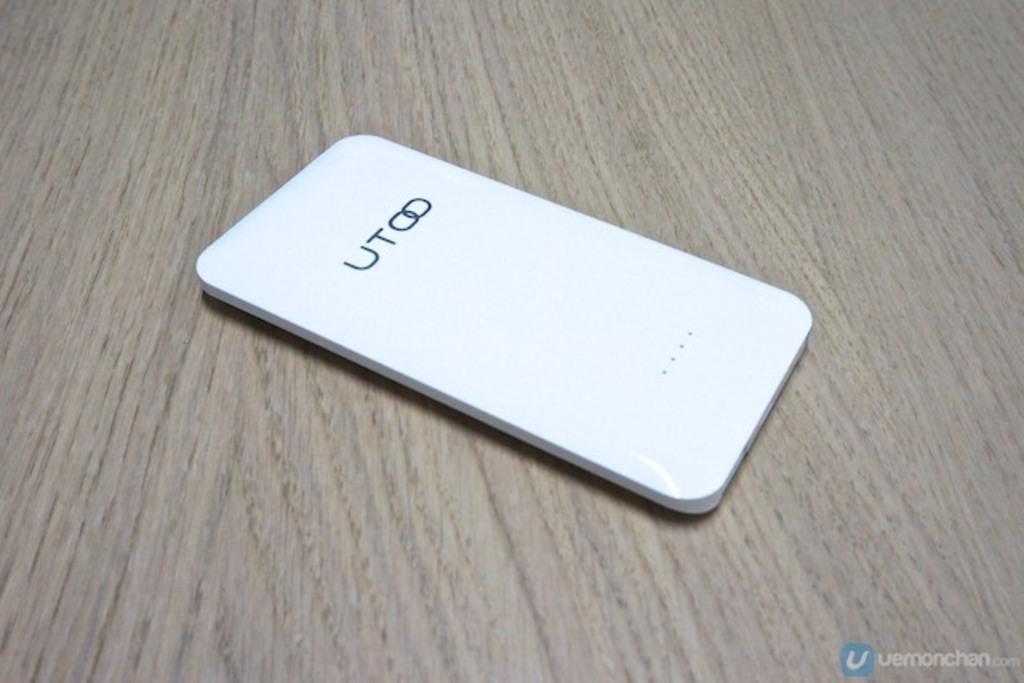How would you summarize this image in a sentence or two? In this picture I can see a device on the wooden board, and there is a watermark on the image. 